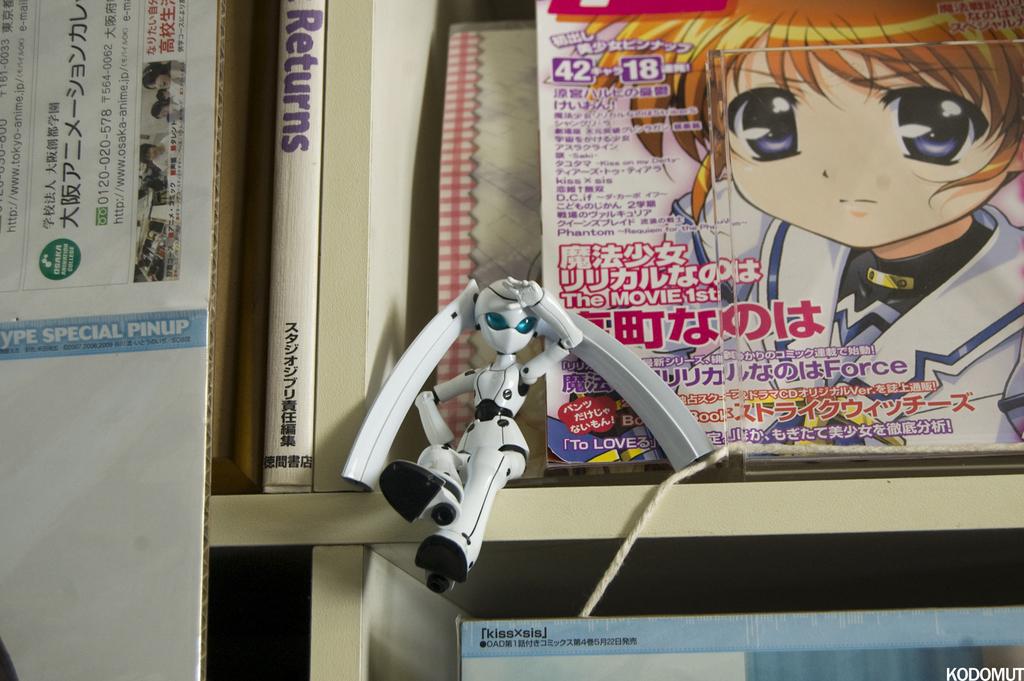Is the pinup special?
Provide a short and direct response. Yes. 